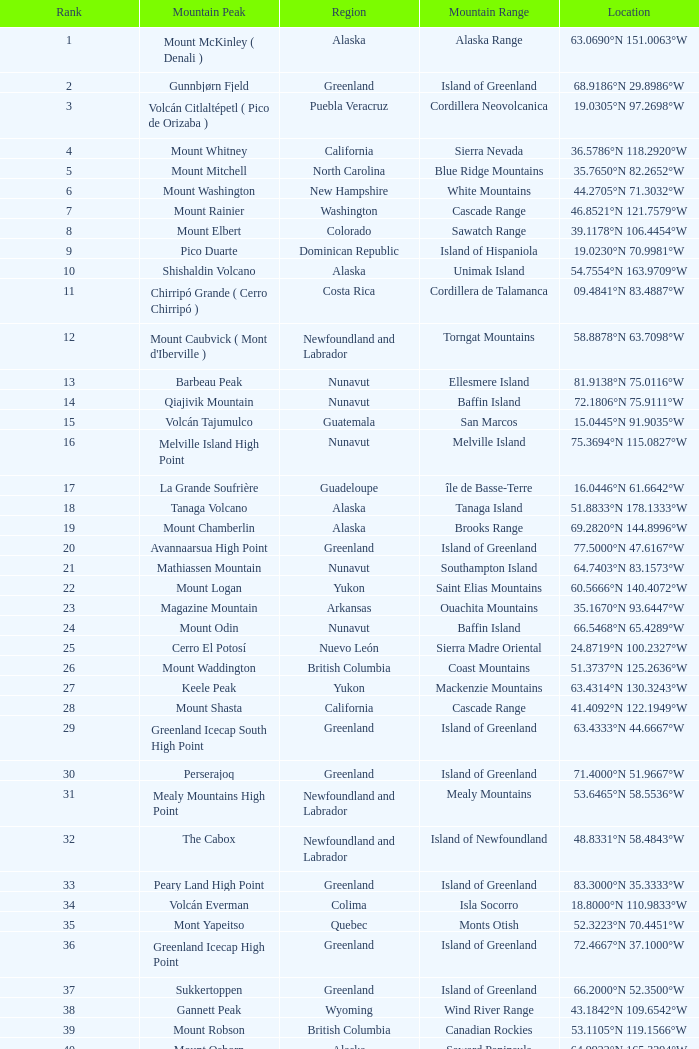Which range of mountains encompasses a part of haiti and a geographic point of 1 Island of Hispaniola. 